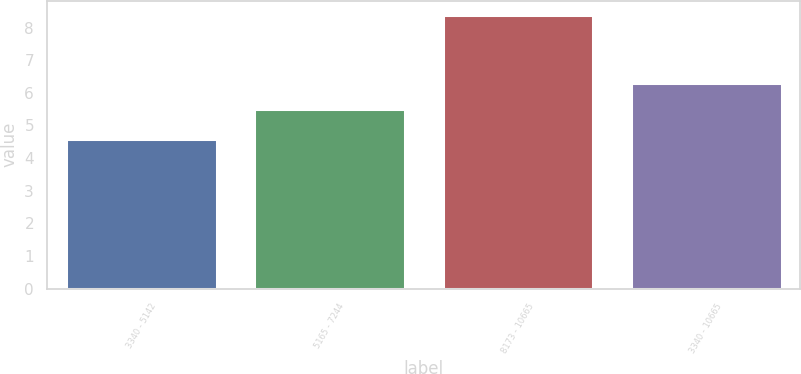<chart> <loc_0><loc_0><loc_500><loc_500><bar_chart><fcel>3340 - 5142<fcel>5165 - 7244<fcel>8173 - 10665<fcel>3340 - 10665<nl><fcel>4.6<fcel>5.5<fcel>8.4<fcel>6.3<nl></chart> 